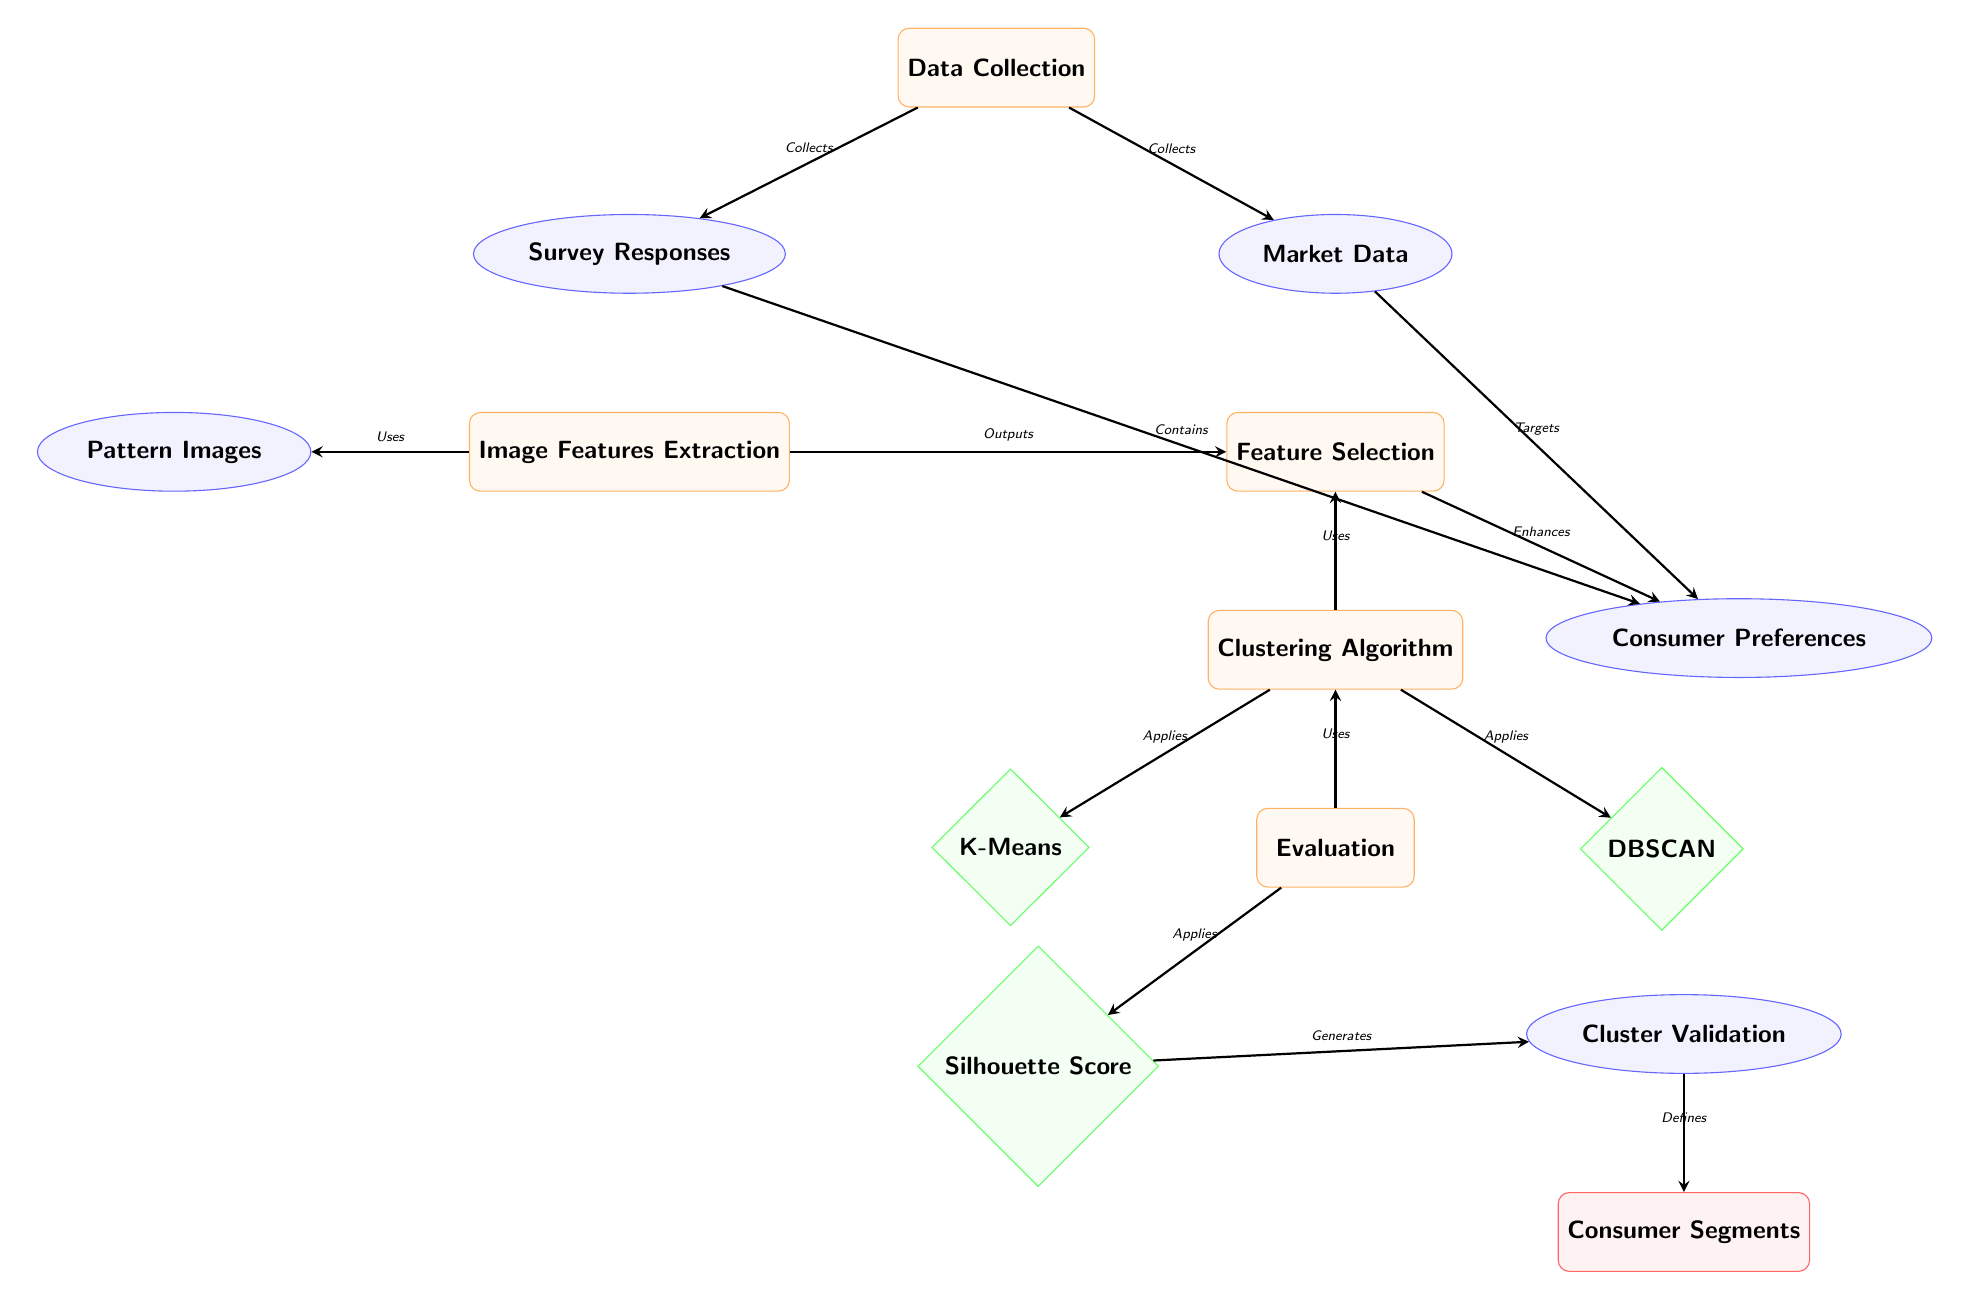What are the two data sources used in the diagram? In the diagram, the two data sources are listed below the Data Collection process: "Survey Responses" and "Market Data."
Answer: Survey Responses, Market Data What process comes after Feature Selection? According to the diagram, after the Feature Selection process, the next process is the Clustering Algorithm.
Answer: Clustering Algorithm How many methods are applied in the Clustering Algorithm? The diagram shows that there are two methods applied under the Clustering Algorithm: "K-Means" and "DBSCAN." Therefore, the count is two.
Answer: 2 What is generated from the Silhouette Score? The Silhouette Score, as illustrated in the diagram, generates the Cluster Validation, which is located to the right of the Silhouette Score.
Answer: Cluster Validation What connects Evaluation to Clustering in the diagram? In the diagram, the connection from Evaluation to Clustering is labeled as "Uses," indicating that the Evaluation process utilizes the Clustering process.
Answer: Uses What does the Data Collection node output? The Data Collection node has arrows pointing to two nodes: Survey Responses and Market Data. Therefore, it outputs these two elements as its results.
Answer: Survey Responses, Market Data Describe the relationship between Consumer Preferences and Feature Selection. Consumer Preferences is connected to the Feature Selection process through an arrow labeled "Enhances," which shows that Feature Selection enhances the understanding of Consumer Preferences.
Answer: Enhances What is the final output of the diagram? The final output, as shown at the bottom of the diagram, is "Consumer Segments," which is the result of the entire process flow leading up from the various stages.
Answer: Consumer Segments 